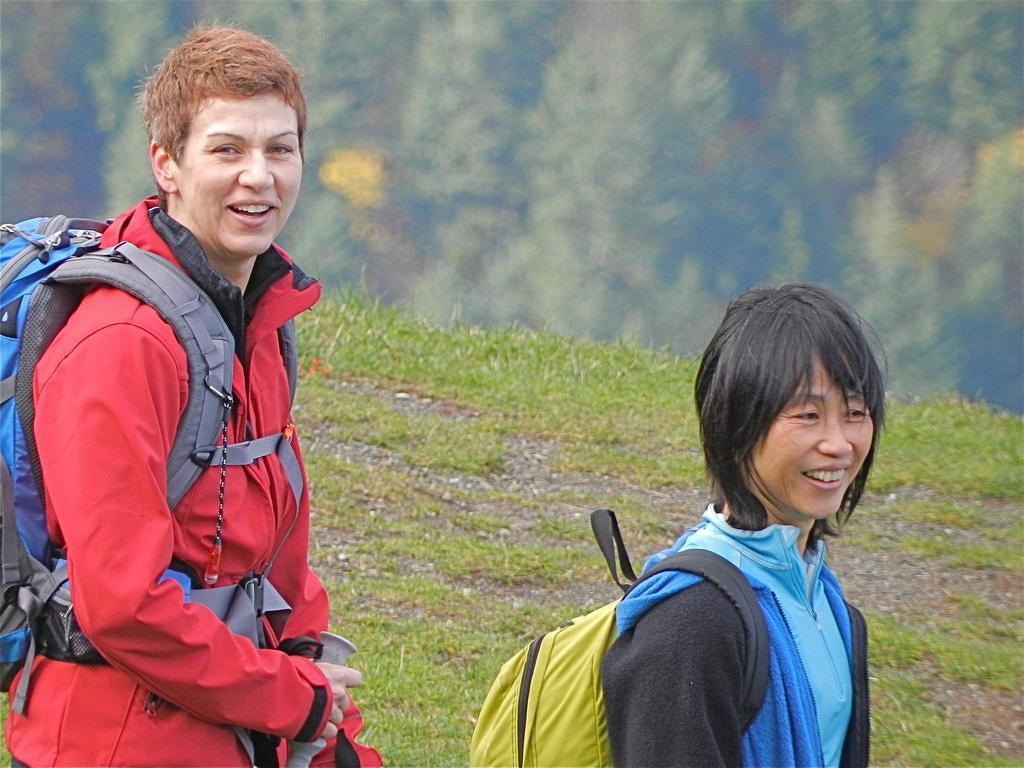In one or two sentences, can you explain what this image depicts? There are two women holding bag and smiling. On the ground there is grass. In the background it is blurred. 